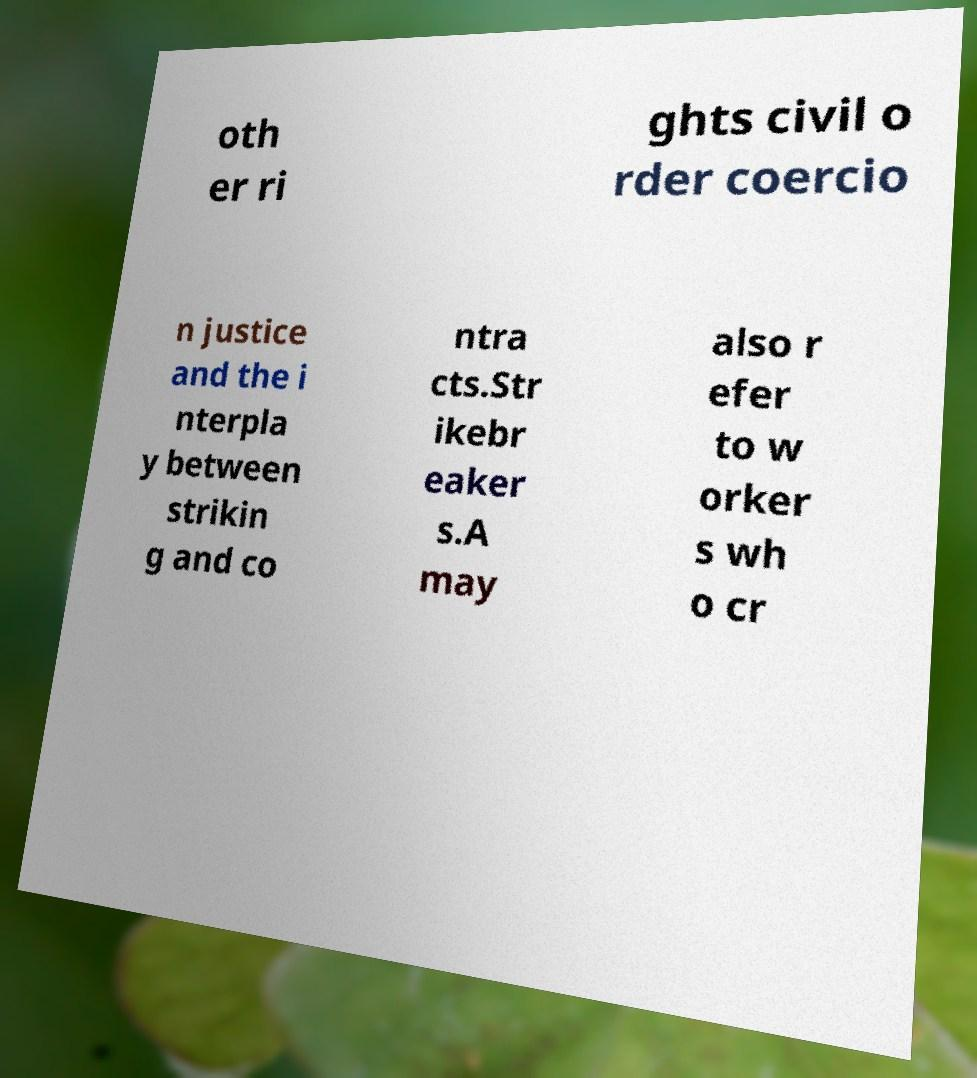Can you read and provide the text displayed in the image?This photo seems to have some interesting text. Can you extract and type it out for me? oth er ri ghts civil o rder coercio n justice and the i nterpla y between strikin g and co ntra cts.Str ikebr eaker s.A may also r efer to w orker s wh o cr 